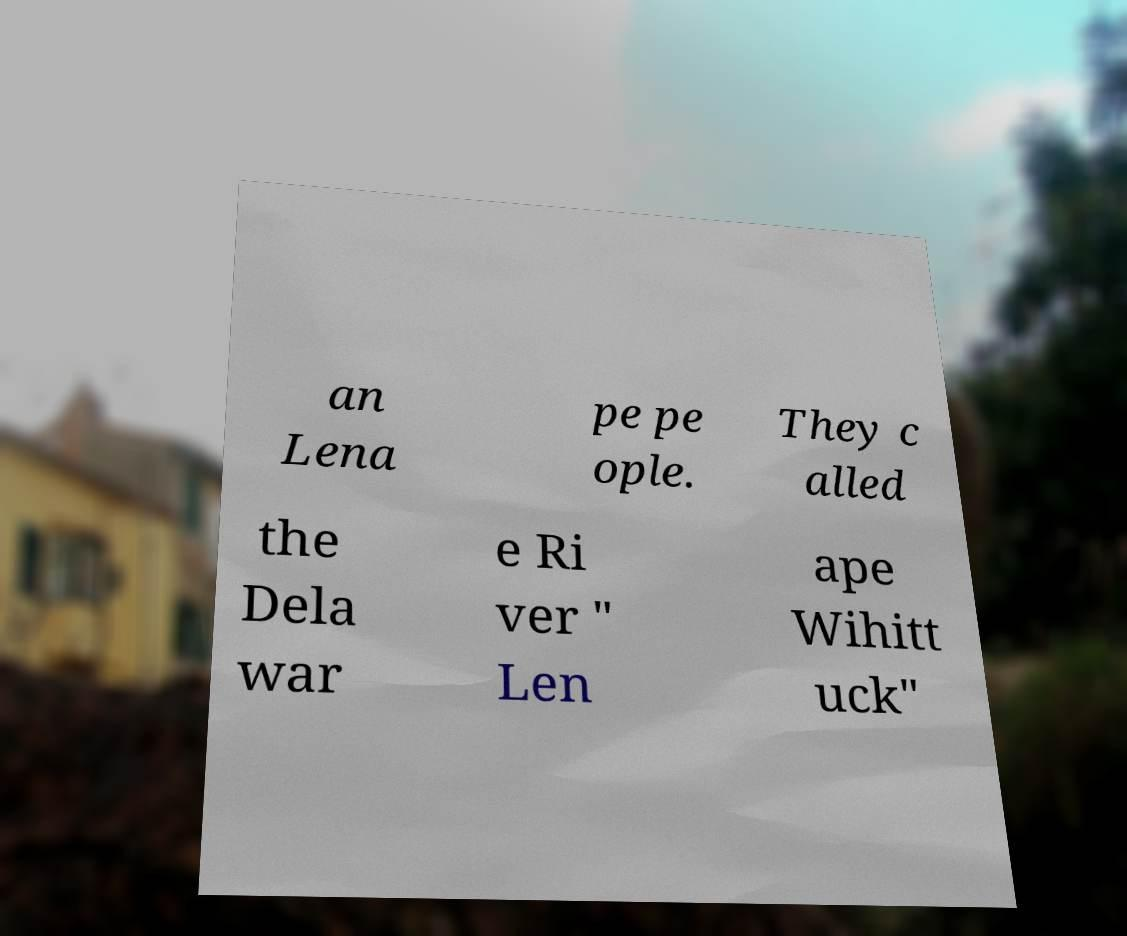I need the written content from this picture converted into text. Can you do that? an Lena pe pe ople. They c alled the Dela war e Ri ver " Len ape Wihitt uck" 